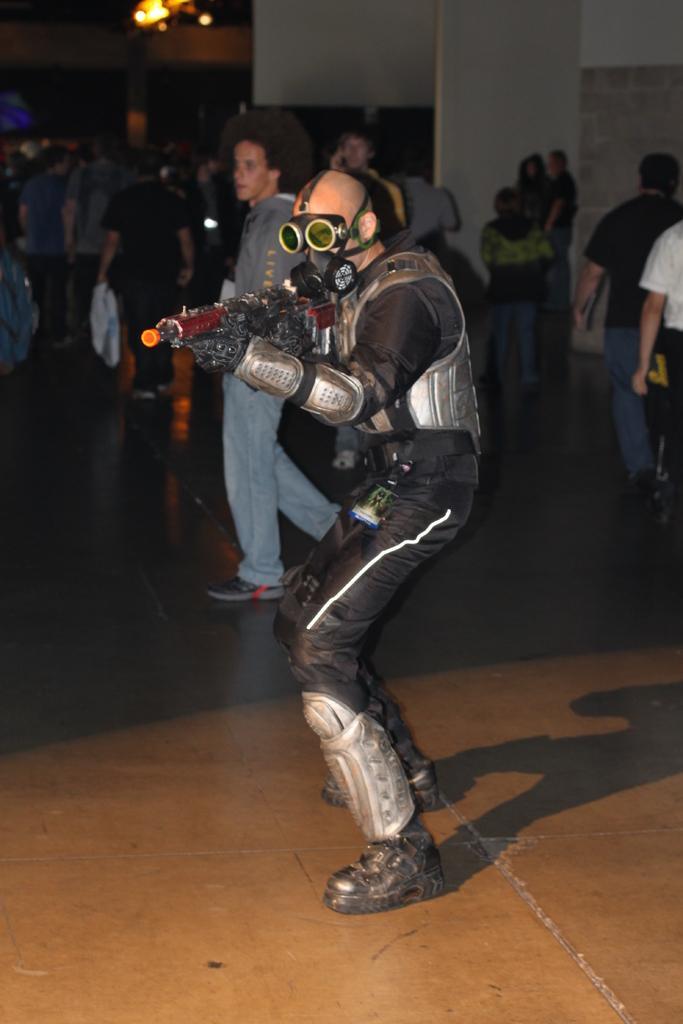Please provide a concise description of this image. Here we can see a man is standing on the floor by holding a gun in his hand and aiming. In the background there are few people standing,walking and few are carrying bags in their hands,wall,pillar and lights. 